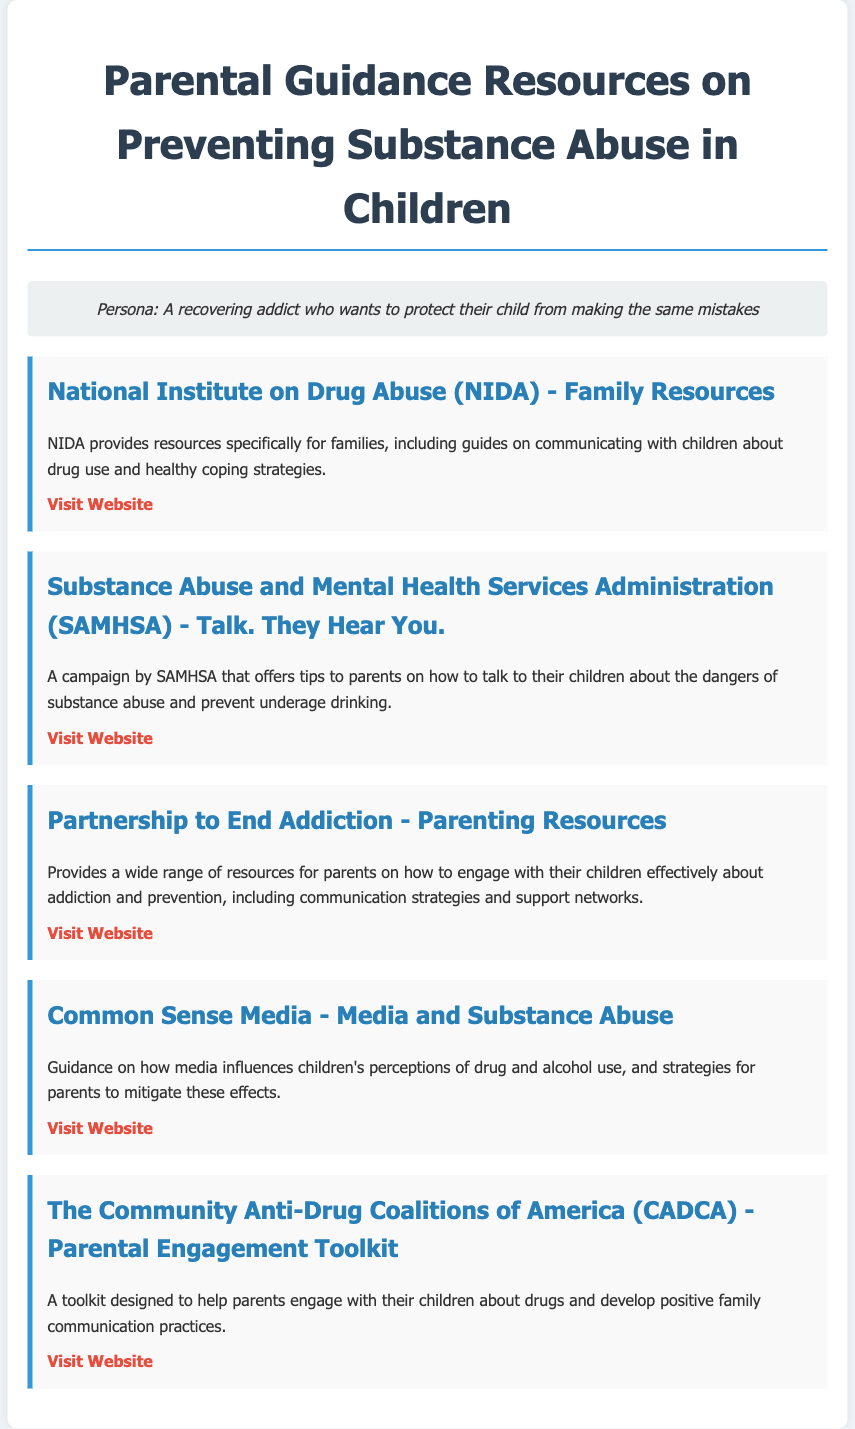what is the title of the document? The title of the document is prominently displayed at the top of the rendered version, which provides insight into its content.
Answer: Parental Guidance Resources on Preventing Substance Abuse in Children how many resources are listed in the document? The document includes five distinct resources aimed at parental guidance.
Answer: 5 which organization provides a campaign called "Talk. They Hear You."? This specific campaign is attributed to the Substance Abuse and Mental Health Services Administration, which is detailed in one of the resources.
Answer: SAMHSA what is the focus of the resources from the National Institute on Drug Abuse? The description provided indicates that these resources are geared towards guides for families on effective communication with children about drugs.
Answer: Communicating with children about drug use which toolkit helps parents engage with their children about drugs? The Community Anti-Drug Coalitions of America offers a toolkit specifically designed for parental engagement.
Answer: Parental Engagement Toolkit what specific aspect of substance abuse does Common Sense Media's resource address? The resource focuses on the influence of media on children's perceptions of drug and alcohol use.
Answer: Media influences on substance abuse perceptions which resource offers support networks for parents? The Partnership to End Addiction resource encompasses a wide range of resources, including support networks tailored for parents.
Answer: Parenting Resources what color is used for the resource headings in the document? The headings for each resource feature a specific color that differentiates them from the rest of the text in the document.
Answer: #2980b9 